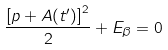<formula> <loc_0><loc_0><loc_500><loc_500>\frac { \left [ p + A ( t ^ { \prime } ) \right ] ^ { 2 } } { 2 } + E _ { \beta } = 0</formula> 